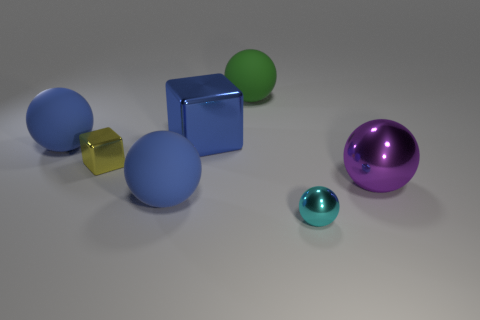Is the large ball that is left of the tiny cube made of the same material as the green sphere?
Provide a succinct answer. Yes. Are there any objects that have the same color as the large metal block?
Ensure brevity in your answer.  Yes. Is the shape of the large blue object that is in front of the yellow shiny thing the same as the big metallic thing that is behind the purple shiny object?
Ensure brevity in your answer.  No. Is there a cube that has the same material as the large purple sphere?
Your answer should be compact. Yes. What number of gray objects are big metallic things or metallic objects?
Your answer should be very brief. 0. What size is the shiny thing that is both to the right of the green ball and behind the cyan metallic thing?
Ensure brevity in your answer.  Large. Is the number of tiny yellow objects in front of the purple object greater than the number of green metallic things?
Your answer should be compact. No. What number of cylinders are small green matte things or large matte things?
Offer a very short reply. 0. The shiny object that is in front of the large blue metal block and left of the large green sphere has what shape?
Your answer should be very brief. Cube. Are there an equal number of tiny metallic blocks left of the small metal block and balls left of the big green sphere?
Provide a succinct answer. No. 